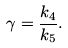Convert formula to latex. <formula><loc_0><loc_0><loc_500><loc_500>\gamma = \frac { k _ { 4 } } { k _ { 5 } } .</formula> 